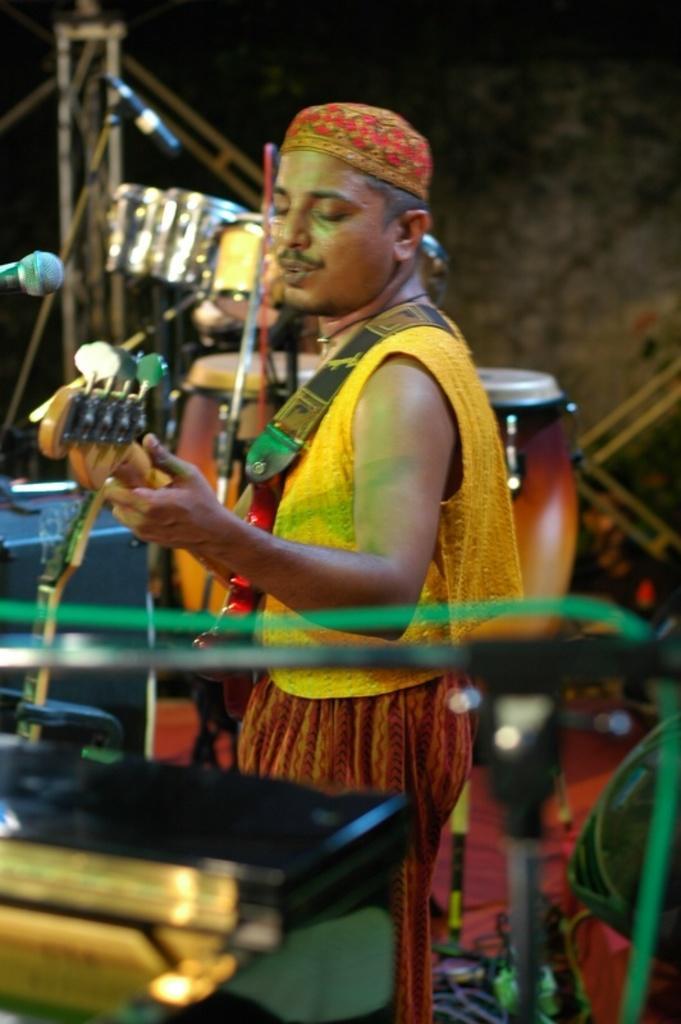In one or two sentences, can you explain what this image depicts? In this image in the center there is one person who is standing and he is holding a guitar, and in the background there are some drums and mikes at the bottom there are some tables wires and some other objects. In the background there is a wall. 